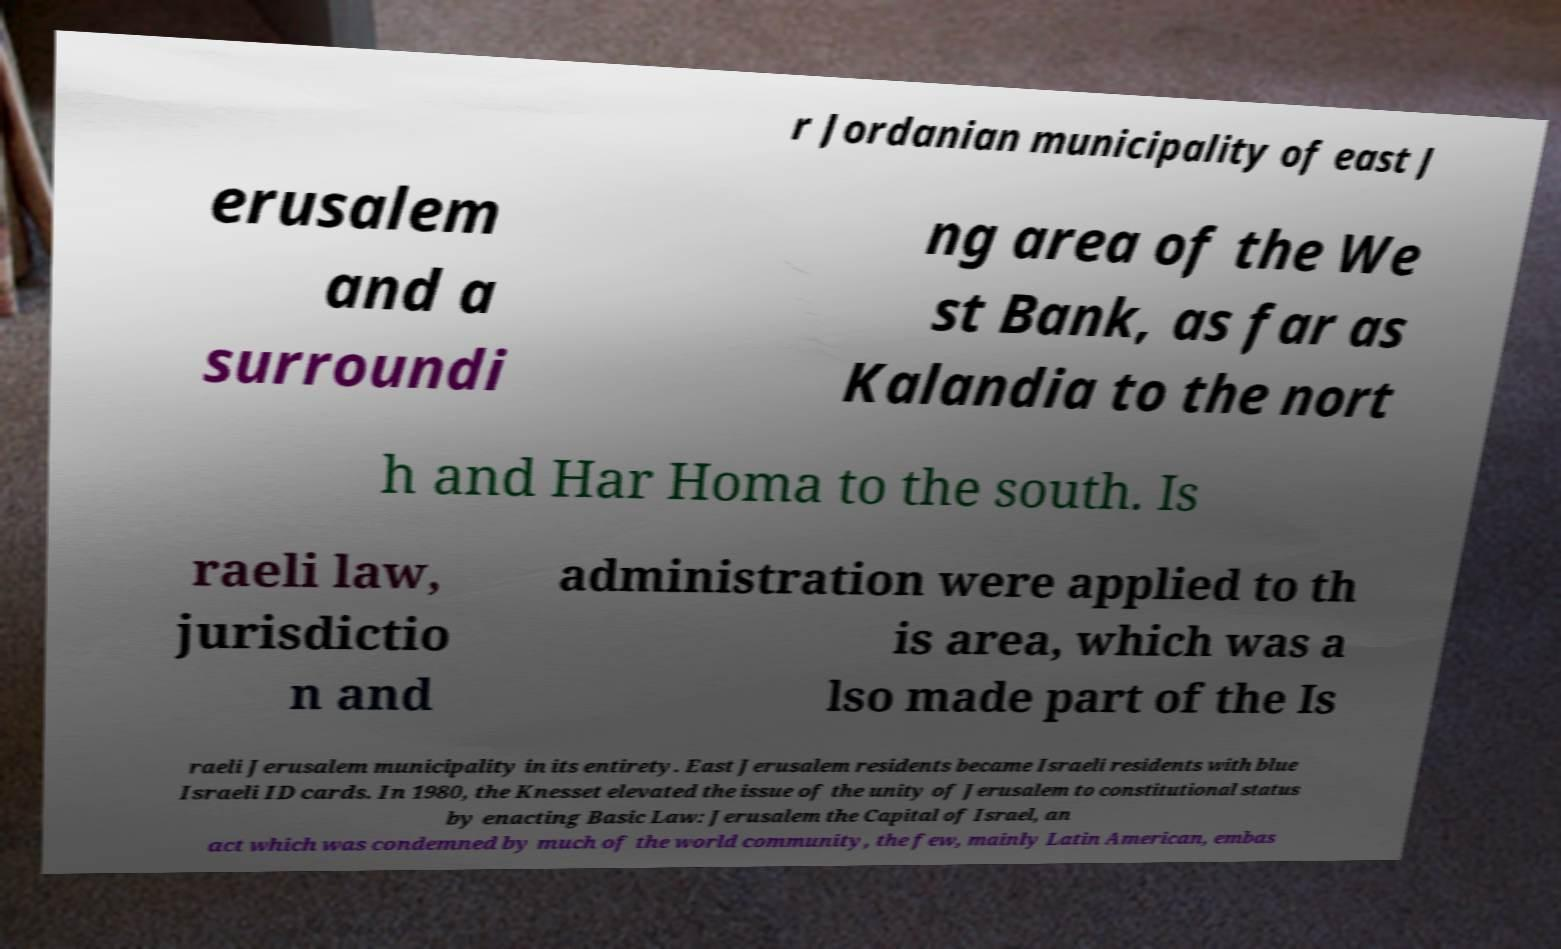Can you read and provide the text displayed in the image?This photo seems to have some interesting text. Can you extract and type it out for me? r Jordanian municipality of east J erusalem and a surroundi ng area of the We st Bank, as far as Kalandia to the nort h and Har Homa to the south. Is raeli law, jurisdictio n and administration were applied to th is area, which was a lso made part of the Is raeli Jerusalem municipality in its entirety. East Jerusalem residents became Israeli residents with blue Israeli ID cards. In 1980, the Knesset elevated the issue of the unity of Jerusalem to constitutional status by enacting Basic Law: Jerusalem the Capital of Israel, an act which was condemned by much of the world community, the few, mainly Latin American, embas 